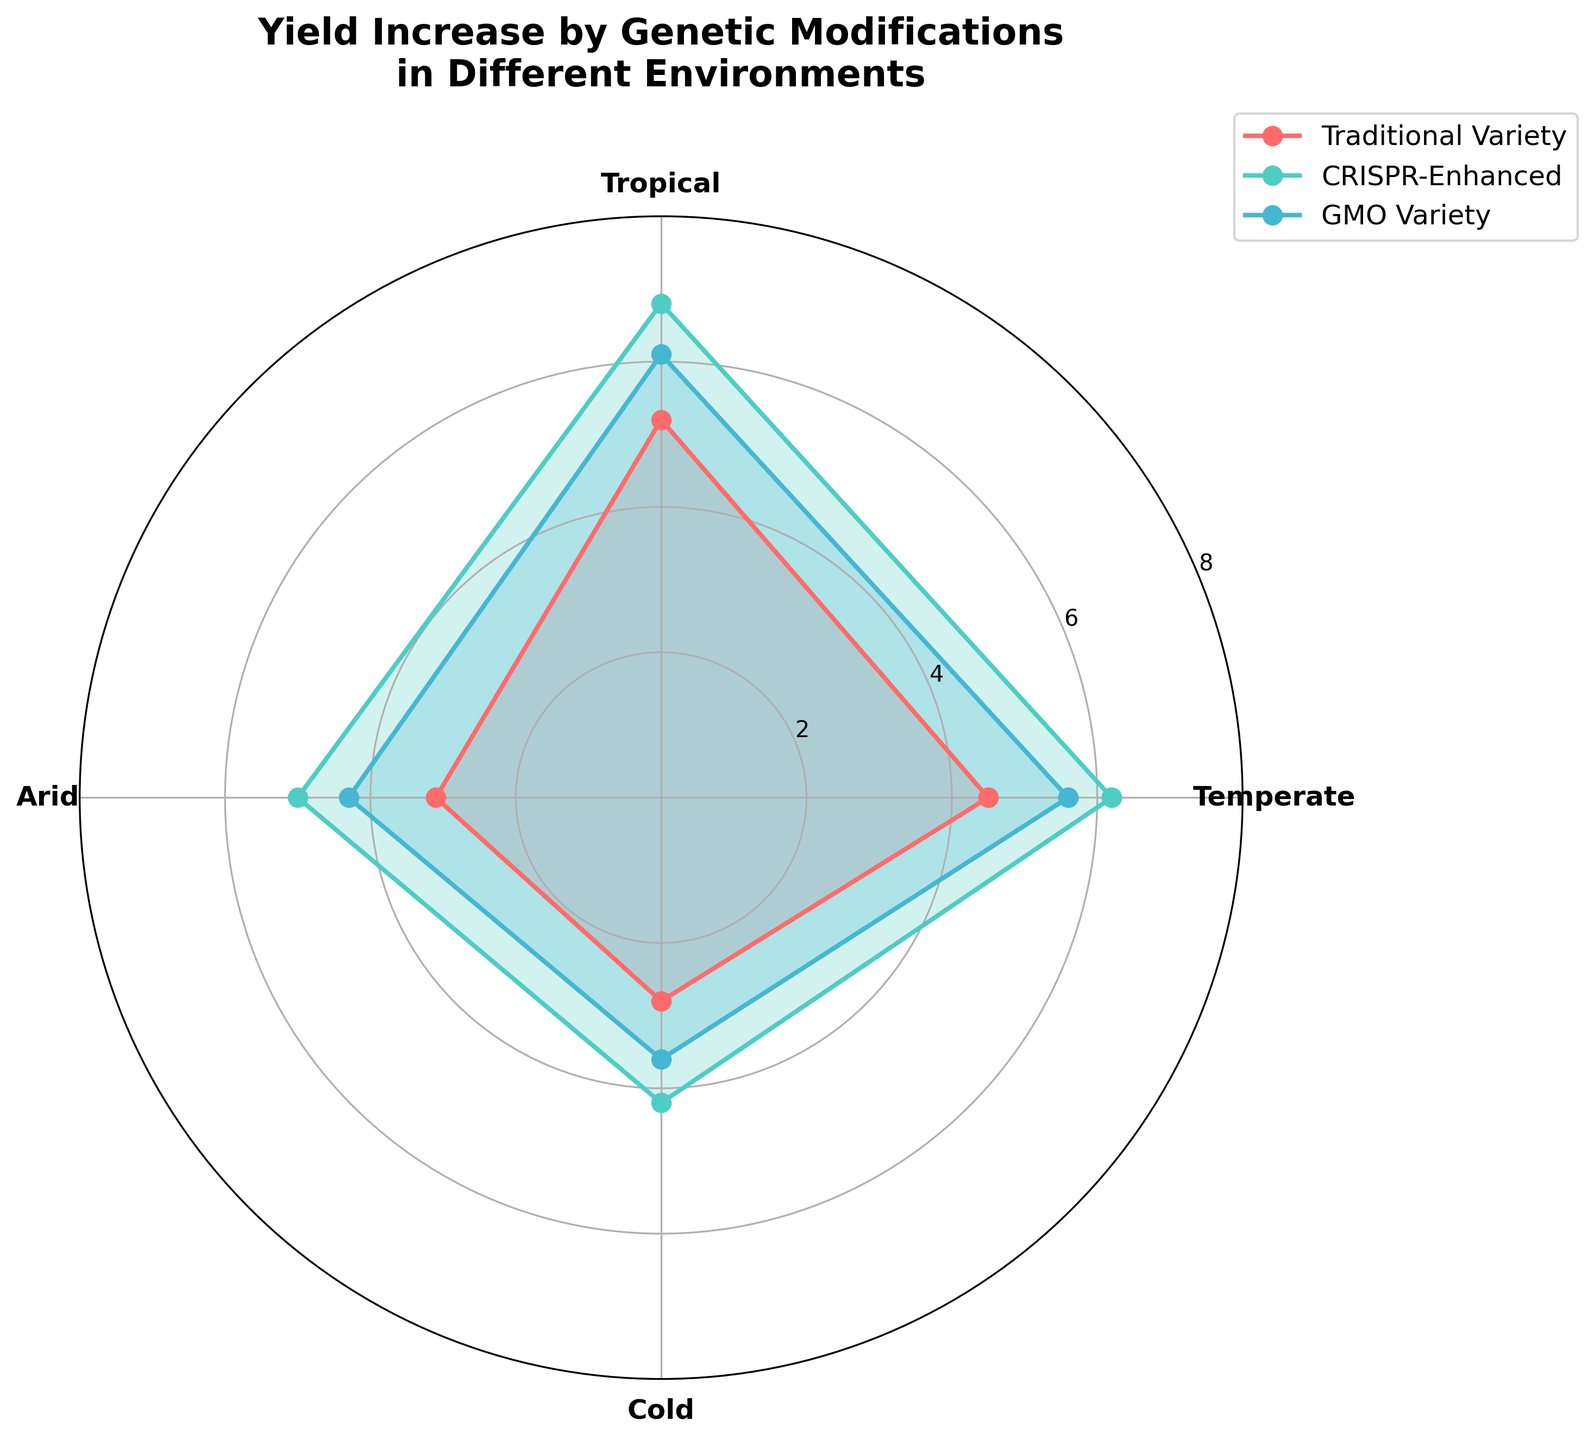What's the title of the figure? The title is located at the top of the figure, typically written in a large and bold font to summarize the content of the chart. It reads, "Yield Increase by Genetic Modifications in Different Environments".
Answer: Yield Increase by Genetic Modifications in Different Environments Which environment showed the highest yield increase for CRISPR-Enhanced varieties? To find this, look for the highest radial point on the plot corresponding to the CRISPR-Enhanced variety, which can be distinguished by its unique color. The label of the environment at this highest point will tell us the answer.
Answer: Tropical What's the yield increase for GMO Varieties in the Arid environment? Locate the Arid section of the chart and follow the line for GMO Varieties. The value corresponding to the intersection of this line and the radial axis gives the yield increase.
Answer: 4.3 Which genetic modification variety generally shows the lowest yields across environments? By comparing the radial lengths across all environments for each variety, identify the one with the consistently shortest lengths, indicating the lowest yields.
Answer: Traditional Variety Compare the yield increase for Epigenetically Modified varieties between Temperate and Cold environments. How much higher is it in the Temperate environment? Check the yield values for Epigenetically Modified varieties in the Temperate and Cold sections. Subtract the Cold environment value from the Temperate environment value. Yield in Temperate: 5.8, in Cold: 3.9. Difference: 5.8 - 3.9 = 1.9.
Answer: 1.9 What is the average yield increase for GMO Varieties across all environments? Sum the yield increases for GMO Varieties in all environments and divide by the number of environments. Total: 5.6 (Temperate) + 6.1 (Tropical) + 4.3 (Arid) + 3.6 (Cold) = 19.6. Average: 19.6 / 4 = 4.9.
Answer: 4.9 Which environment shows the least difference in yield increase between Traditional and CRISPR-Enhanced varieties? Subtract the yield values for Traditional from CRISPR-Enhanced varieties for each environment and compare. The smallest difference indicates the environment with the least variation. Differences: Temperate: 6.2 - 4.5 = 1.7, Tropical: 6.8 - 5.2 = 1.6, Arid: 5.0 - 3.1 = 1.9, Cold: 4.2 - 2.8 = 1.4.
Answer: Cold Which variety shows the most improvement in yield in Arid environments compared to Traditional Variety? Compare the increase in yields for all genetically modified varieties (CRISPR-Enhanced, Epigenetically Modified, and GMO) to that of the Traditional Variety in the Arid environment. Then identify which one has the largest improvement. Traditional: 3.1, CRISPR-Enhanced: 5.0, Epigenetically Modified: 4.7, GMO: 4.3. Improvements: CRISPR-Enhanced: 5.0 - 3.1 = 1.9, Epigenetically Modified: 4.7 - 3.1 = 1.6, GMO: 4.3 - 3.1 = 1.2.
Answer: CRISPR-Enhanced What is the total yield increase for Traditional Varieties across all environments? Sum the yield increases for Traditional Varieties in all environments. Temperate: 4.5, Tropical: 5.2, Arid: 3.1, Cold: 2.8. Total: 4.5 + 5.2 + 3.1 + 2.8 = 15.6.
Answer: 15.6 How much higher is the average yield increase for CRISPR-Enhanced varieties compared to Traditional Varieties? Calculate the average yield increase for both CRISPR-Enhanced and Traditional Varieties and subtract the averages. CRISPR-Enhanced: (6.2 + 6.8 + 5.0 + 4.2) / 4 = 5.55. Traditional: (4.5 + 5.2 + 3.1 + 2.8) / 4 = 3.9. Difference: 5.55 - 3.9 = 1.65.
Answer: 1.65 